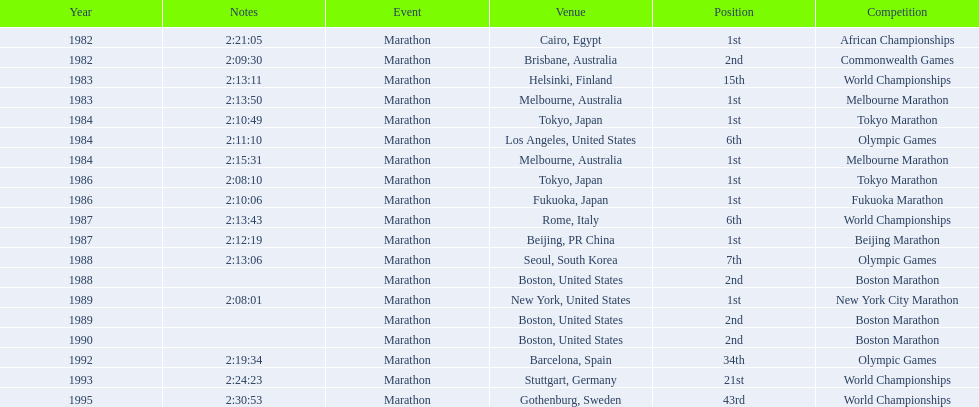What are all the competitions? African Championships, Commonwealth Games, World Championships, Melbourne Marathon, Tokyo Marathon, Olympic Games, Melbourne Marathon, Tokyo Marathon, Fukuoka Marathon, World Championships, Beijing Marathon, Olympic Games, Boston Marathon, New York City Marathon, Boston Marathon, Boston Marathon, Olympic Games, World Championships, World Championships. Where were they located? Cairo, Egypt, Brisbane, Australia, Helsinki, Finland, Melbourne, Australia, Tokyo, Japan, Los Angeles, United States, Melbourne, Australia, Tokyo, Japan, Fukuoka, Japan, Rome, Italy, Beijing, PR China, Seoul, South Korea, Boston, United States, New York, United States, Boston, United States, Boston, United States, Barcelona, Spain, Stuttgart, Germany, Gothenburg, Sweden. And which competition was in china? Beijing Marathon. 